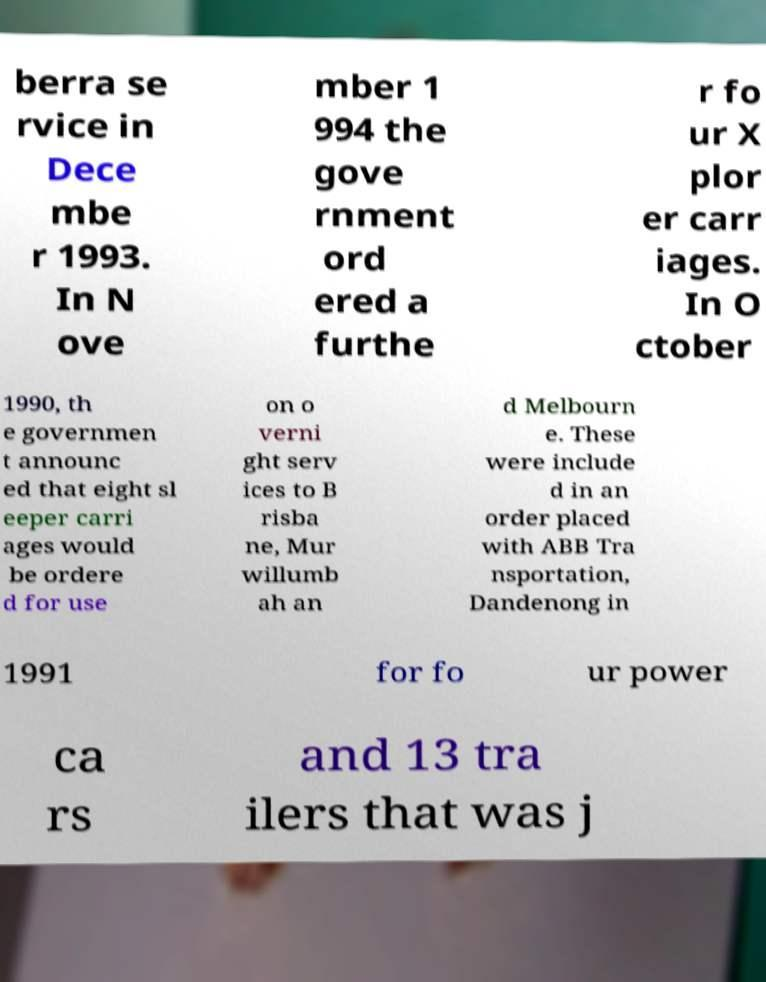I need the written content from this picture converted into text. Can you do that? berra se rvice in Dece mbe r 1993. In N ove mber 1 994 the gove rnment ord ered a furthe r fo ur X plor er carr iages. In O ctober 1990, th e governmen t announc ed that eight sl eeper carri ages would be ordere d for use on o verni ght serv ices to B risba ne, Mur willumb ah an d Melbourn e. These were include d in an order placed with ABB Tra nsportation, Dandenong in 1991 for fo ur power ca rs and 13 tra ilers that was j 